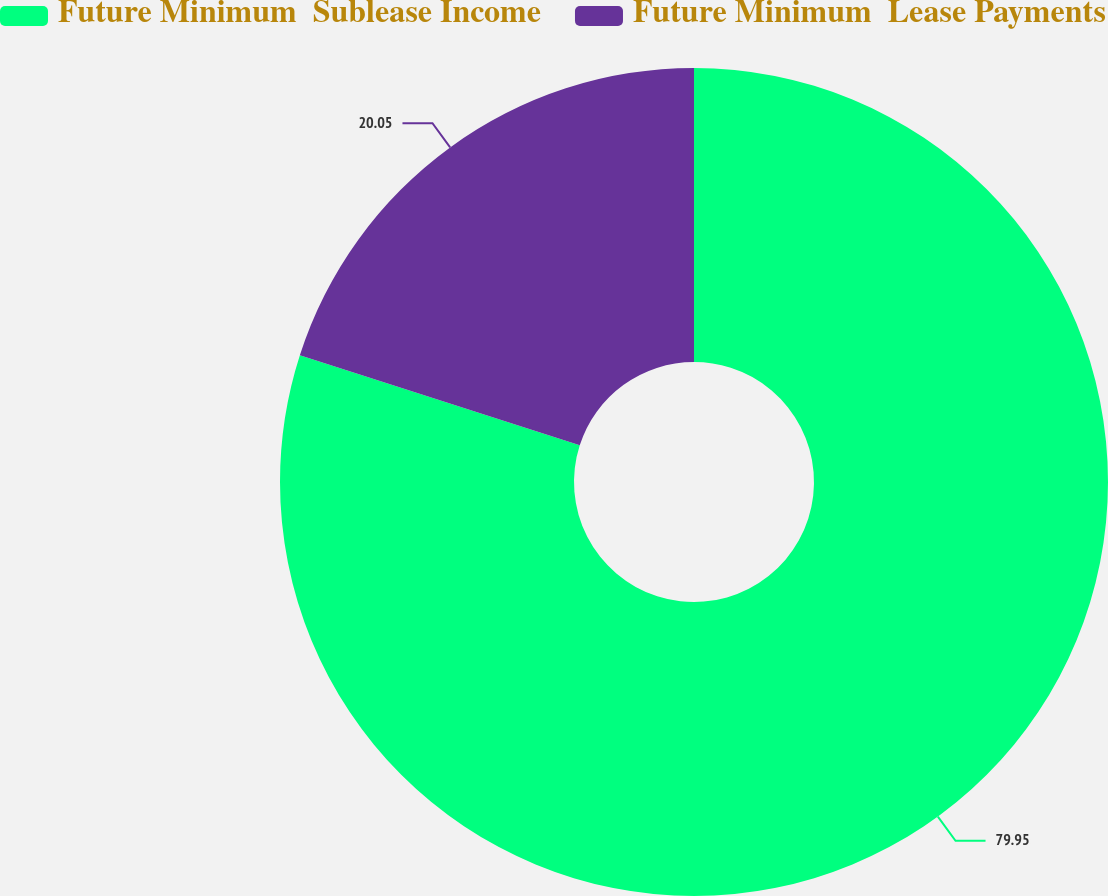Convert chart to OTSL. <chart><loc_0><loc_0><loc_500><loc_500><pie_chart><fcel>Future Minimum  Sublease Income<fcel>Future Minimum  Lease Payments<nl><fcel>79.95%<fcel>20.05%<nl></chart> 